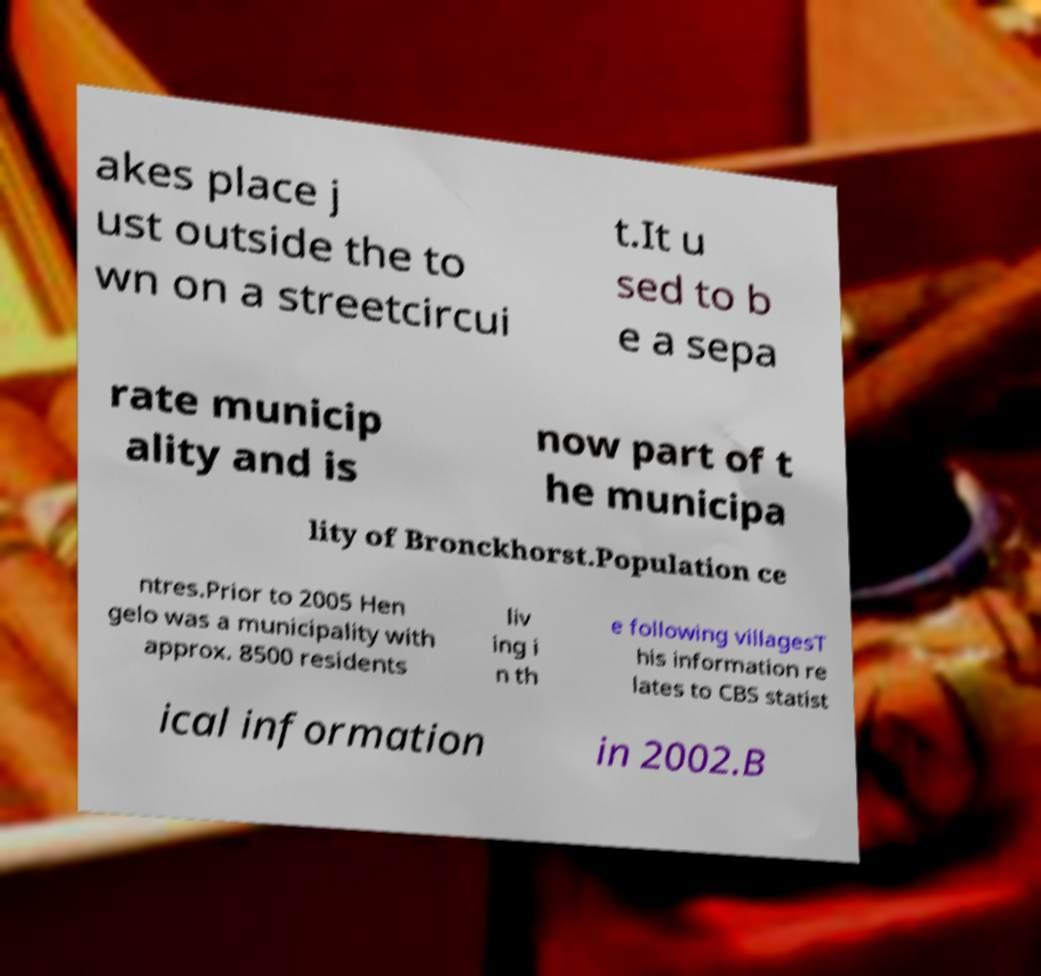Could you assist in decoding the text presented in this image and type it out clearly? akes place j ust outside the to wn on a streetcircui t.It u sed to b e a sepa rate municip ality and is now part of t he municipa lity of Bronckhorst.Population ce ntres.Prior to 2005 Hen gelo was a municipality with approx. 8500 residents liv ing i n th e following villagesT his information re lates to CBS statist ical information in 2002.B 